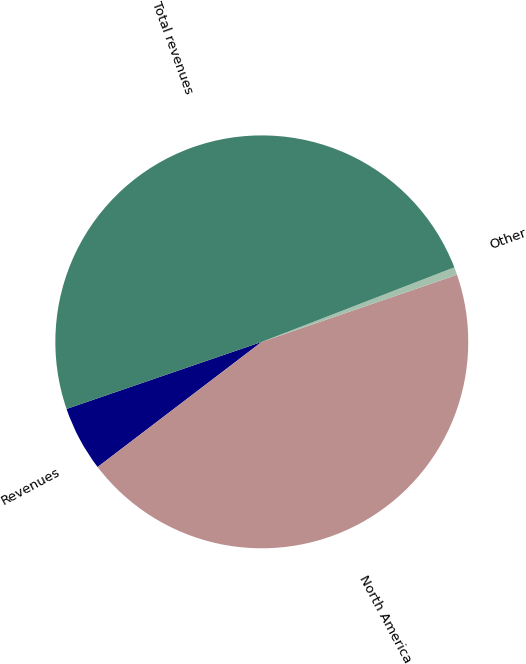Convert chart to OTSL. <chart><loc_0><loc_0><loc_500><loc_500><pie_chart><fcel>Revenues<fcel>North America<fcel>Other<fcel>Total revenues<nl><fcel>5.1%<fcel>44.9%<fcel>0.61%<fcel>49.39%<nl></chart> 